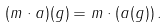Convert formula to latex. <formula><loc_0><loc_0><loc_500><loc_500>( m \cdot a ) ( g ) = m \cdot ( a ( g ) ) \, .</formula> 